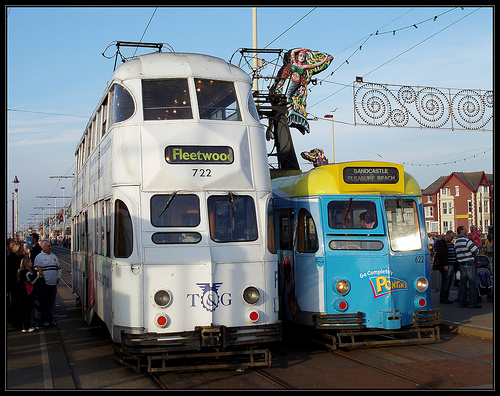<image>
Is there a man to the left of the man? Yes. From this viewpoint, the man is positioned to the left side relative to the man. 